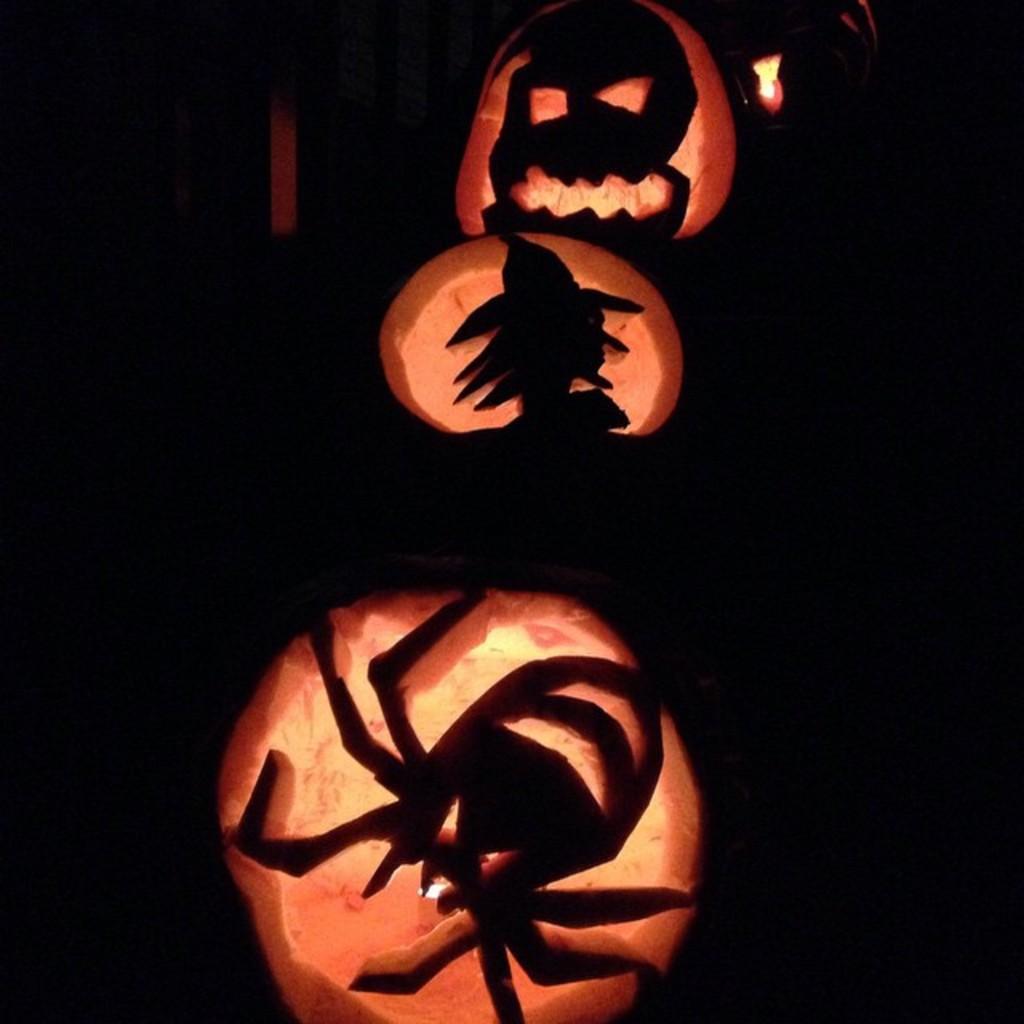Please provide a concise description of this image. In this picture we can see the jack-o'-lanterns. In the background, the image is dark. 